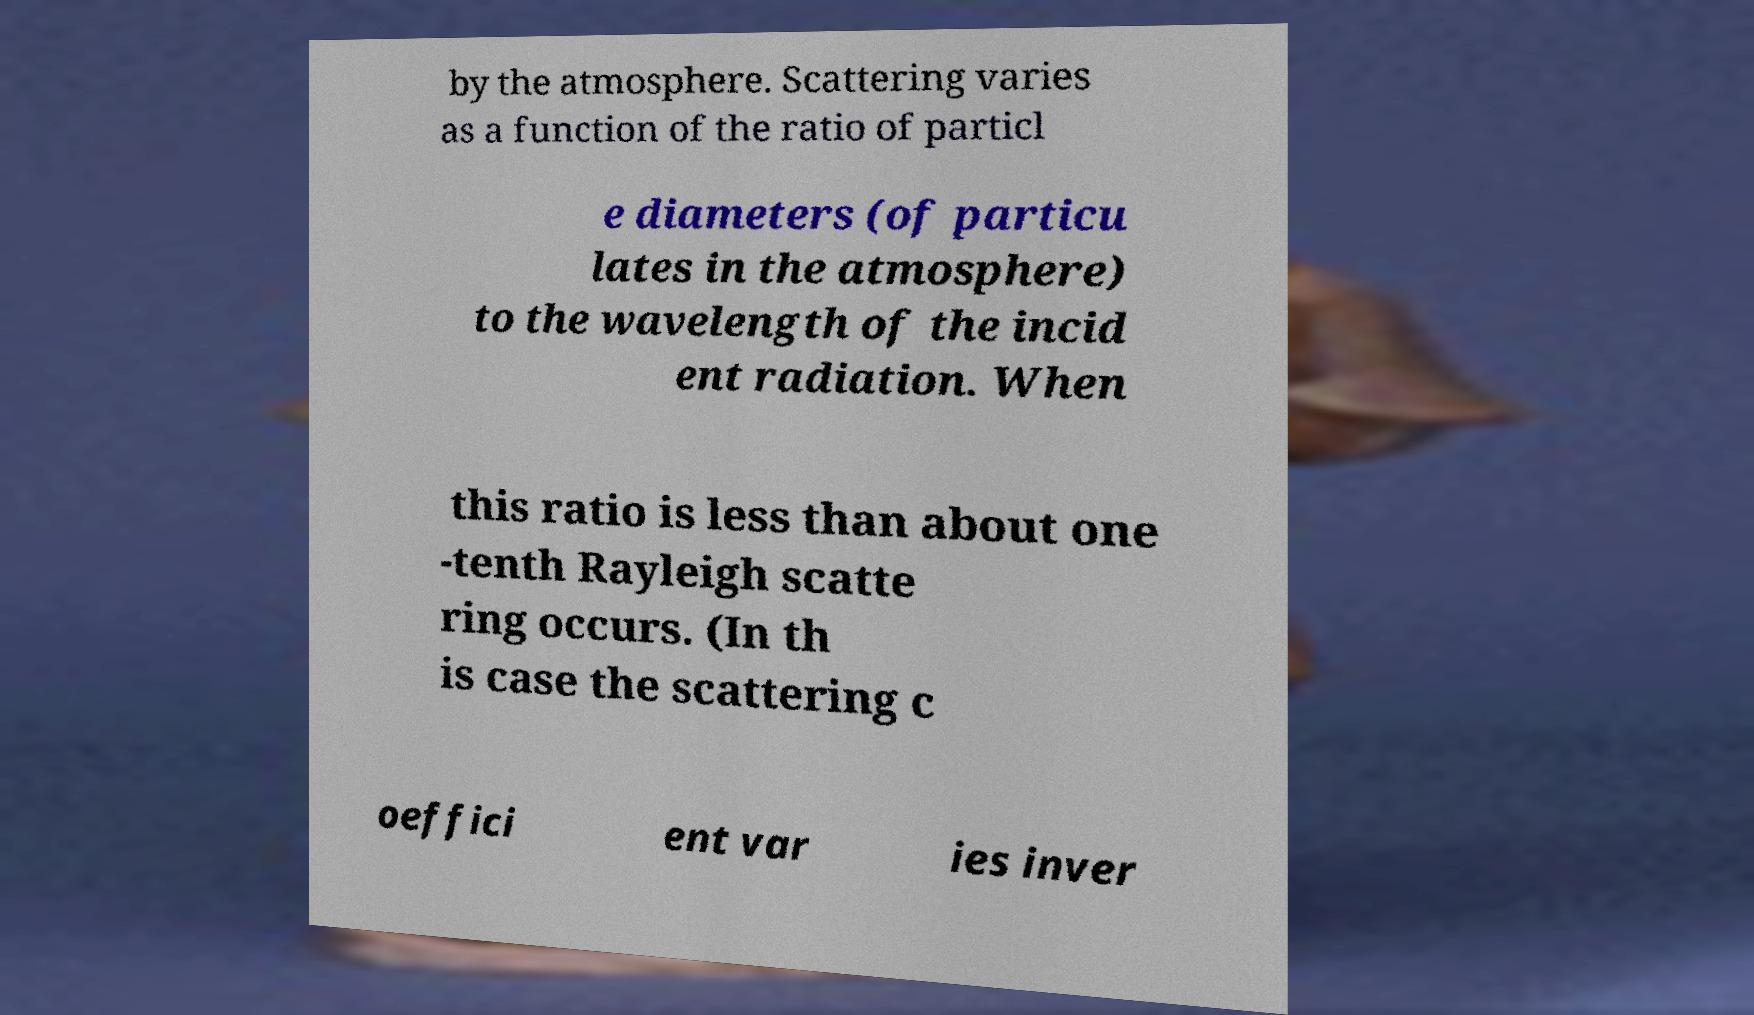I need the written content from this picture converted into text. Can you do that? by the atmosphere. Scattering varies as a function of the ratio of particl e diameters (of particu lates in the atmosphere) to the wavelength of the incid ent radiation. When this ratio is less than about one -tenth Rayleigh scatte ring occurs. (In th is case the scattering c oeffici ent var ies inver 